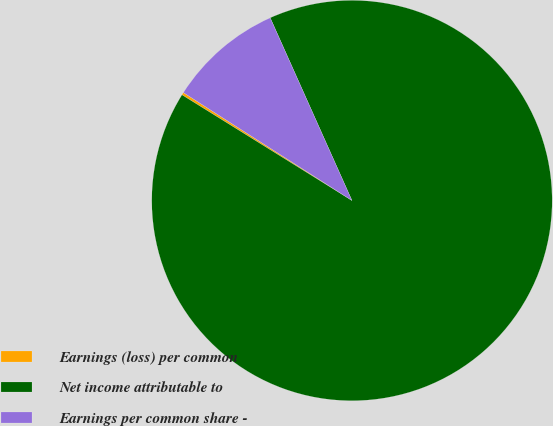Convert chart. <chart><loc_0><loc_0><loc_500><loc_500><pie_chart><fcel>Earnings (loss) per common<fcel>Net income attributable to<fcel>Earnings per common share -<nl><fcel>0.21%<fcel>90.55%<fcel>9.24%<nl></chart> 